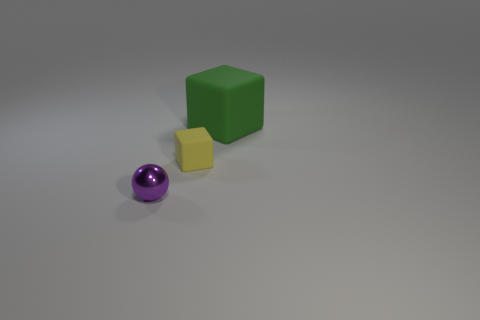Add 3 tiny green rubber blocks. How many objects exist? 6 Subtract 1 cubes. How many cubes are left? 1 Subtract all balls. How many objects are left? 2 Subtract 0 cyan spheres. How many objects are left? 3 Subtract all gray cubes. Subtract all yellow cylinders. How many cubes are left? 2 Subtract all big red cylinders. Subtract all tiny metallic objects. How many objects are left? 2 Add 2 purple spheres. How many purple spheres are left? 3 Add 3 cyan balls. How many cyan balls exist? 3 